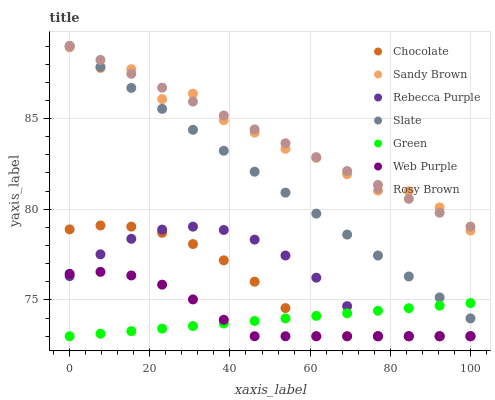Does Green have the minimum area under the curve?
Answer yes or no. Yes. Does Rosy Brown have the maximum area under the curve?
Answer yes or no. Yes. Does Chocolate have the minimum area under the curve?
Answer yes or no. No. Does Chocolate have the maximum area under the curve?
Answer yes or no. No. Is Slate the smoothest?
Answer yes or no. Yes. Is Sandy Brown the roughest?
Answer yes or no. Yes. Is Rosy Brown the smoothest?
Answer yes or no. No. Is Rosy Brown the roughest?
Answer yes or no. No. Does Chocolate have the lowest value?
Answer yes or no. Yes. Does Rosy Brown have the lowest value?
Answer yes or no. No. Does Rosy Brown have the highest value?
Answer yes or no. Yes. Does Chocolate have the highest value?
Answer yes or no. No. Is Web Purple less than Rosy Brown?
Answer yes or no. Yes. Is Slate greater than Chocolate?
Answer yes or no. Yes. Does Rosy Brown intersect Slate?
Answer yes or no. Yes. Is Rosy Brown less than Slate?
Answer yes or no. No. Is Rosy Brown greater than Slate?
Answer yes or no. No. Does Web Purple intersect Rosy Brown?
Answer yes or no. No. 